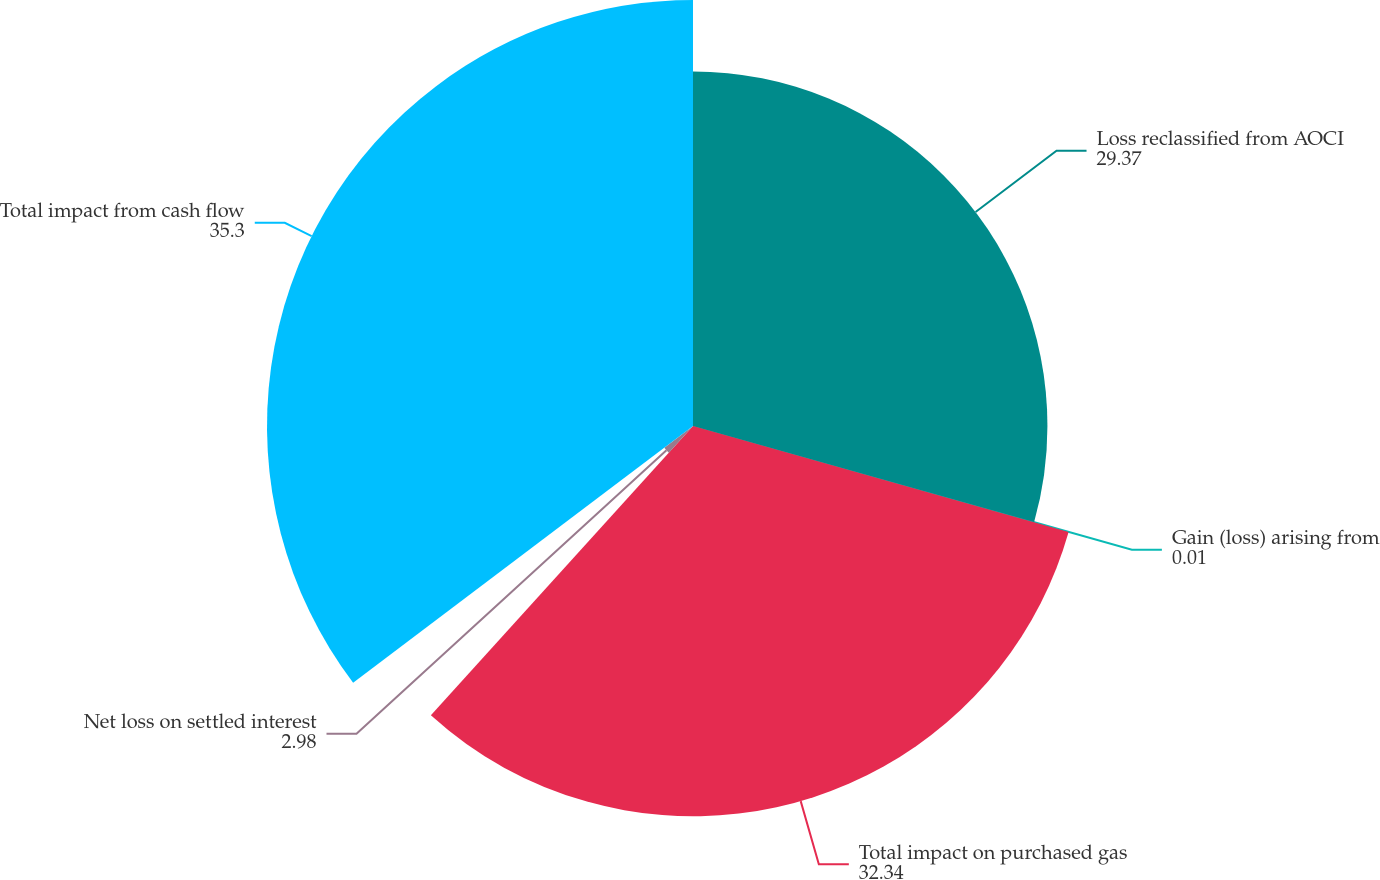Convert chart to OTSL. <chart><loc_0><loc_0><loc_500><loc_500><pie_chart><fcel>Loss reclassified from AOCI<fcel>Gain (loss) arising from<fcel>Total impact on purchased gas<fcel>Net loss on settled interest<fcel>Total impact from cash flow<nl><fcel>29.37%<fcel>0.01%<fcel>32.34%<fcel>2.98%<fcel>35.3%<nl></chart> 